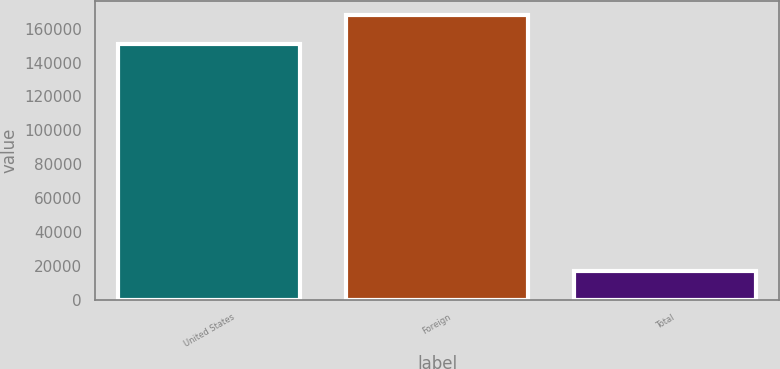Convert chart to OTSL. <chart><loc_0><loc_0><loc_500><loc_500><bar_chart><fcel>United States<fcel>Foreign<fcel>Total<nl><fcel>151083<fcel>168228<fcel>17145<nl></chart> 